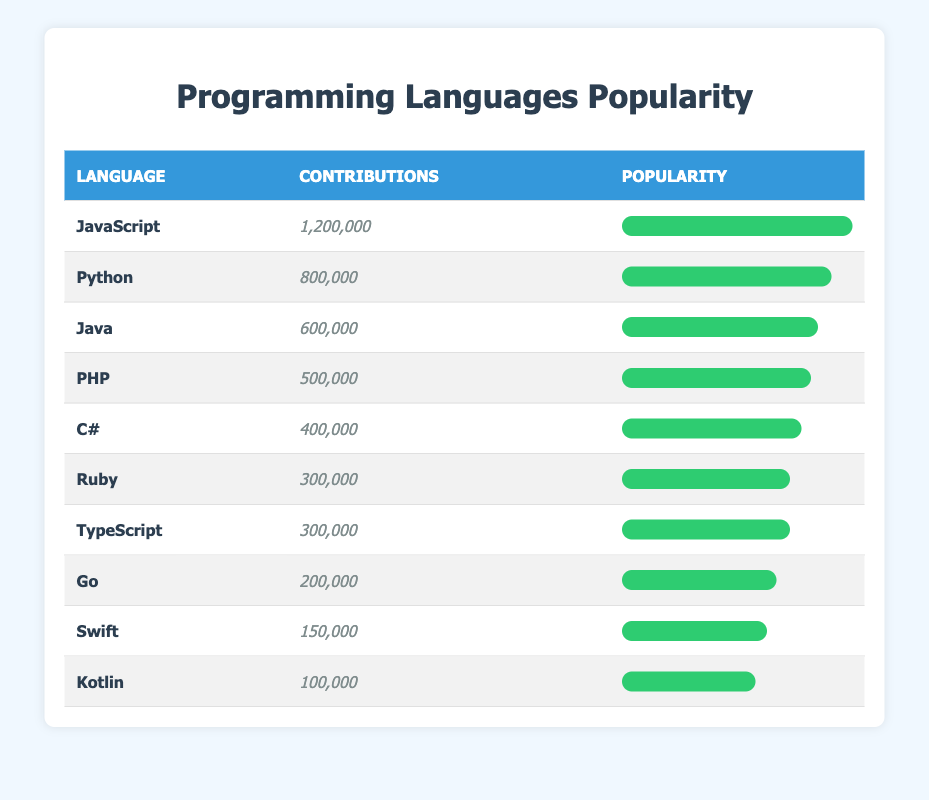What is the total number of contributions from all programming languages listed in the table? To find the total contributions, first, we sum up the contributions of each language: 1200000 (JavaScript) + 800000 (Python) + 600000 (Java) + 500000 (PHP) + 400000 (C#) + 300000 (Ruby) + 300000 (TypeScript) + 200000 (Go) + 150000 (Swift) + 100000 (Kotlin) = 3000000.
Answer: 3000000 Which programming language has the second highest number of contributions? By looking at the contributions, JavaScript has 1200000, and the next highest is Python with 800000. Thus, Python is the second highest.
Answer: Python Is the number of contributions for Ruby greater than the contributions for Go? Ruby has 300000 contributions, while Go has 200000. Since 300000 is greater than 200000, the statement is true.
Answer: Yes What is the difference in contributions between Java and C#? Java has 600000 contributions, and C# has 400000. To find the difference, we subtract 400000 from 600000, which gives us 200000.
Answer: 200000 What percentage of the total contributions do JavaScript's contributions represent? First, we find the fraction of JavaScript's contributions (1200000) over the total contributions (3000000). Then, we multiply by 100 to convert it to a percentage: (1200000 / 3000000) * 100 = 40%.
Answer: 40% Which languages have contributions greater than 250000? Looking at the contributions, the languages with more than 250000 are JavaScript (1200000), Python (800000), Java (600000), PHP (500000), C# (400000), Ruby (300000), and TypeScript (300000). Thus, there are seven languages.
Answer: 7 What is the median number of contributions among the programming languages listed? First, we arrange the contributions in ascending order: 100000 (Kotlin), 150000 (Swift), 200000 (Go), 300000 (Ruby), 300000 (TypeScript), 400000 (C#), 500000 (PHP), 600000 (Java), 800000 (Python), 1200000 (JavaScript). The median, being the average of the 5th and 6th values (300000 and 400000), is (300000 + 400000)/2 = 350000.
Answer: 350000 Which language has the lowest contribution? By reviewing the table, Kotlin, with 100000 contributions, has the lowest number of contributions listed.
Answer: Kotlin 